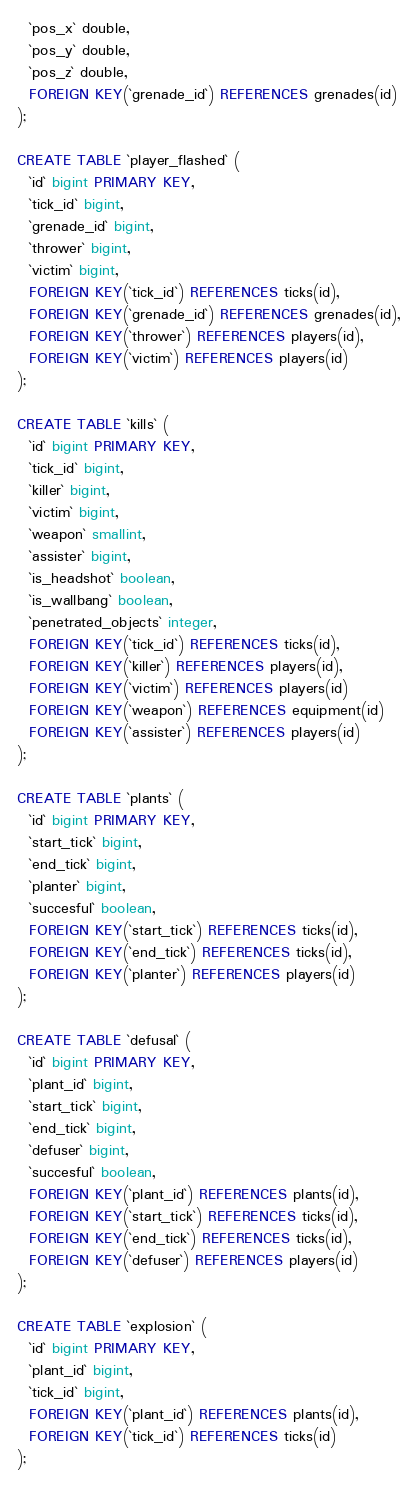<code> <loc_0><loc_0><loc_500><loc_500><_SQL_>  `pos_x` double,
  `pos_y` double,
  `pos_z` double,
  FOREIGN KEY(`grenade_id`) REFERENCES grenades(id)
);

CREATE TABLE `player_flashed` (
  `id` bigint PRIMARY KEY,
  `tick_id` bigint,
  `grenade_id` bigint,
  `thrower` bigint,
  `victim` bigint,
  FOREIGN KEY(`tick_id`) REFERENCES ticks(id),
  FOREIGN KEY(`grenade_id`) REFERENCES grenades(id),
  FOREIGN KEY(`thrower`) REFERENCES players(id),
  FOREIGN KEY(`victim`) REFERENCES players(id)
);

CREATE TABLE `kills` (
  `id` bigint PRIMARY KEY,
  `tick_id` bigint,
  `killer` bigint,
  `victim` bigint,
  `weapon` smallint,
  `assister` bigint,
  `is_headshot` boolean,
  `is_wallbang` boolean,
  `penetrated_objects` integer,
  FOREIGN KEY(`tick_id`) REFERENCES ticks(id),
  FOREIGN KEY(`killer`) REFERENCES players(id),
  FOREIGN KEY(`victim`) REFERENCES players(id)
  FOREIGN KEY(`weapon`) REFERENCES equipment(id)
  FOREIGN KEY(`assister`) REFERENCES players(id)
);

CREATE TABLE `plants` (
  `id` bigint PRIMARY KEY,
  `start_tick` bigint,
  `end_tick` bigint,
  `planter` bigint,
  `succesful` boolean,
  FOREIGN KEY(`start_tick`) REFERENCES ticks(id),
  FOREIGN KEY(`end_tick`) REFERENCES ticks(id),
  FOREIGN KEY(`planter`) REFERENCES players(id)
);

CREATE TABLE `defusal` (
  `id` bigint PRIMARY KEY,
  `plant_id` bigint,
  `start_tick` bigint,
  `end_tick` bigint,
  `defuser` bigint,
  `succesful` boolean,
  FOREIGN KEY(`plant_id`) REFERENCES plants(id),
  FOREIGN KEY(`start_tick`) REFERENCES ticks(id),
  FOREIGN KEY(`end_tick`) REFERENCES ticks(id),
  FOREIGN KEY(`defuser`) REFERENCES players(id)
);

CREATE TABLE `explosion` (
  `id` bigint PRIMARY KEY,
  `plant_id` bigint,
  `tick_id` bigint,
  FOREIGN KEY(`plant_id`) REFERENCES plants(id),
  FOREIGN KEY(`tick_id`) REFERENCES ticks(id)
);
</code> 